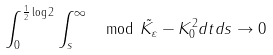<formula> <loc_0><loc_0><loc_500><loc_500>\int _ { 0 } ^ { \frac { 1 } { 2 } \log 2 } \int _ { s } ^ { \infty } \mod { \tilde { K _ { \varepsilon } } - K _ { 0 } } ^ { 2 } d t d s \to 0</formula> 